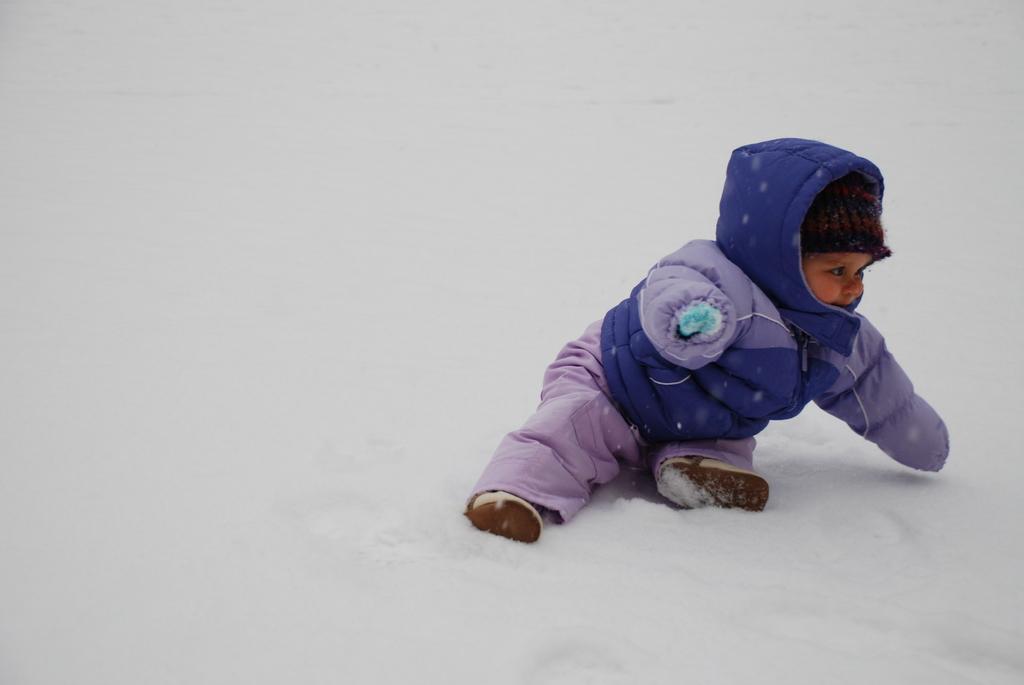Please provide a concise description of this image. There is a baby in a coat which is in violet and gray color combination sitting on a snow surface of a ground. And the background is white in color. 